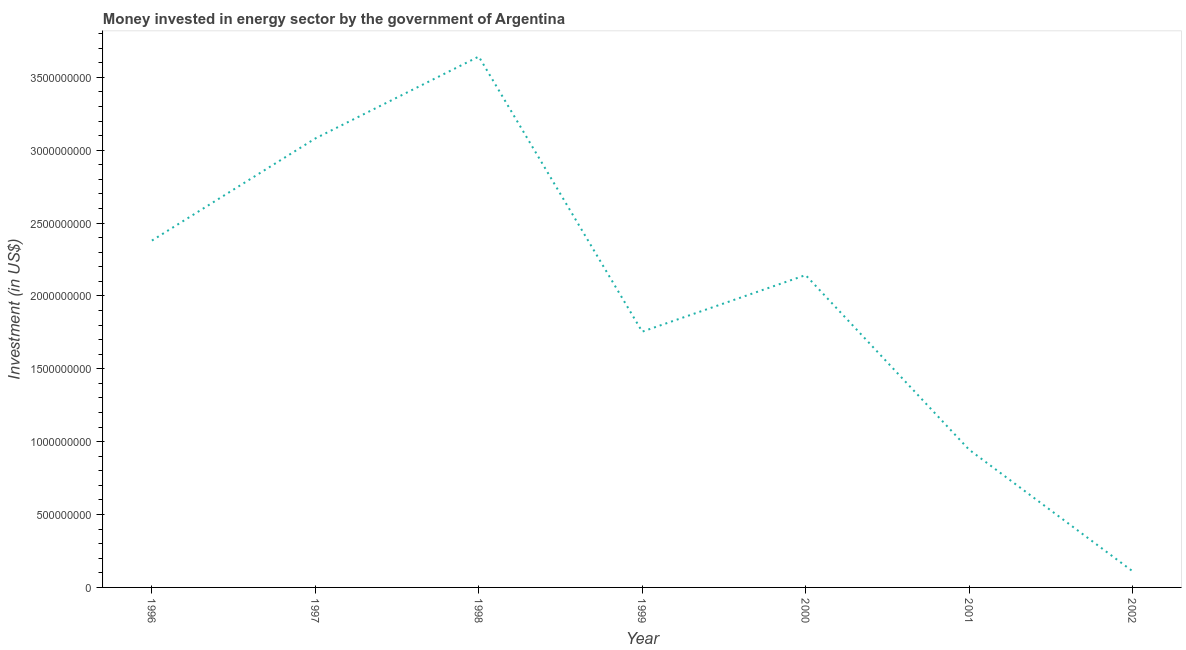What is the investment in energy in 1999?
Offer a terse response. 1.75e+09. Across all years, what is the maximum investment in energy?
Provide a succinct answer. 3.64e+09. Across all years, what is the minimum investment in energy?
Offer a terse response. 1.12e+08. What is the sum of the investment in energy?
Offer a terse response. 1.41e+1. What is the difference between the investment in energy in 1998 and 2001?
Give a very brief answer. 2.70e+09. What is the average investment in energy per year?
Make the answer very short. 2.01e+09. What is the median investment in energy?
Offer a terse response. 2.14e+09. In how many years, is the investment in energy greater than 2100000000 US$?
Make the answer very short. 4. What is the ratio of the investment in energy in 1996 to that in 1997?
Provide a short and direct response. 0.77. Is the investment in energy in 1998 less than that in 2002?
Ensure brevity in your answer.  No. Is the difference between the investment in energy in 1998 and 2000 greater than the difference between any two years?
Offer a very short reply. No. What is the difference between the highest and the second highest investment in energy?
Offer a terse response. 5.62e+08. What is the difference between the highest and the lowest investment in energy?
Your response must be concise. 3.53e+09. In how many years, is the investment in energy greater than the average investment in energy taken over all years?
Give a very brief answer. 4. Does the investment in energy monotonically increase over the years?
Offer a terse response. No. How many years are there in the graph?
Ensure brevity in your answer.  7. What is the difference between two consecutive major ticks on the Y-axis?
Provide a short and direct response. 5.00e+08. What is the title of the graph?
Make the answer very short. Money invested in energy sector by the government of Argentina. What is the label or title of the Y-axis?
Offer a very short reply. Investment (in US$). What is the Investment (in US$) of 1996?
Offer a very short reply. 2.38e+09. What is the Investment (in US$) of 1997?
Your answer should be compact. 3.08e+09. What is the Investment (in US$) of 1998?
Keep it short and to the point. 3.64e+09. What is the Investment (in US$) in 1999?
Give a very brief answer. 1.75e+09. What is the Investment (in US$) in 2000?
Offer a very short reply. 2.14e+09. What is the Investment (in US$) of 2001?
Ensure brevity in your answer.  9.46e+08. What is the Investment (in US$) of 2002?
Provide a short and direct response. 1.12e+08. What is the difference between the Investment (in US$) in 1996 and 1997?
Your response must be concise. -7.01e+08. What is the difference between the Investment (in US$) in 1996 and 1998?
Provide a short and direct response. -1.26e+09. What is the difference between the Investment (in US$) in 1996 and 1999?
Offer a very short reply. 6.25e+08. What is the difference between the Investment (in US$) in 1996 and 2000?
Provide a succinct answer. 2.37e+08. What is the difference between the Investment (in US$) in 1996 and 2001?
Provide a succinct answer. 1.43e+09. What is the difference between the Investment (in US$) in 1996 and 2002?
Offer a terse response. 2.27e+09. What is the difference between the Investment (in US$) in 1997 and 1998?
Offer a terse response. -5.62e+08. What is the difference between the Investment (in US$) in 1997 and 1999?
Ensure brevity in your answer.  1.33e+09. What is the difference between the Investment (in US$) in 1997 and 2000?
Make the answer very short. 9.38e+08. What is the difference between the Investment (in US$) in 1997 and 2001?
Provide a succinct answer. 2.14e+09. What is the difference between the Investment (in US$) in 1997 and 2002?
Make the answer very short. 2.97e+09. What is the difference between the Investment (in US$) in 1998 and 1999?
Offer a very short reply. 1.89e+09. What is the difference between the Investment (in US$) in 1998 and 2000?
Ensure brevity in your answer.  1.50e+09. What is the difference between the Investment (in US$) in 1998 and 2001?
Offer a very short reply. 2.70e+09. What is the difference between the Investment (in US$) in 1998 and 2002?
Your response must be concise. 3.53e+09. What is the difference between the Investment (in US$) in 1999 and 2000?
Your response must be concise. -3.88e+08. What is the difference between the Investment (in US$) in 1999 and 2001?
Your answer should be compact. 8.09e+08. What is the difference between the Investment (in US$) in 1999 and 2002?
Provide a short and direct response. 1.64e+09. What is the difference between the Investment (in US$) in 2000 and 2001?
Your response must be concise. 1.20e+09. What is the difference between the Investment (in US$) in 2000 and 2002?
Your answer should be compact. 2.03e+09. What is the difference between the Investment (in US$) in 2001 and 2002?
Provide a short and direct response. 8.34e+08. What is the ratio of the Investment (in US$) in 1996 to that in 1997?
Make the answer very short. 0.77. What is the ratio of the Investment (in US$) in 1996 to that in 1998?
Give a very brief answer. 0.65. What is the ratio of the Investment (in US$) in 1996 to that in 1999?
Provide a short and direct response. 1.36. What is the ratio of the Investment (in US$) in 1996 to that in 2000?
Your response must be concise. 1.11. What is the ratio of the Investment (in US$) in 1996 to that in 2001?
Your response must be concise. 2.52. What is the ratio of the Investment (in US$) in 1996 to that in 2002?
Give a very brief answer. 21.28. What is the ratio of the Investment (in US$) in 1997 to that in 1998?
Make the answer very short. 0.85. What is the ratio of the Investment (in US$) in 1997 to that in 1999?
Your answer should be compact. 1.75. What is the ratio of the Investment (in US$) in 1997 to that in 2000?
Keep it short and to the point. 1.44. What is the ratio of the Investment (in US$) in 1997 to that in 2001?
Provide a short and direct response. 3.26. What is the ratio of the Investment (in US$) in 1997 to that in 2002?
Offer a very short reply. 27.55. What is the ratio of the Investment (in US$) in 1998 to that in 1999?
Give a very brief answer. 2.08. What is the ratio of the Investment (in US$) in 1998 to that in 2000?
Give a very brief answer. 1.7. What is the ratio of the Investment (in US$) in 1998 to that in 2001?
Offer a terse response. 3.85. What is the ratio of the Investment (in US$) in 1998 to that in 2002?
Your answer should be very brief. 32.57. What is the ratio of the Investment (in US$) in 1999 to that in 2000?
Give a very brief answer. 0.82. What is the ratio of the Investment (in US$) in 1999 to that in 2001?
Ensure brevity in your answer.  1.86. What is the ratio of the Investment (in US$) in 1999 to that in 2002?
Your response must be concise. 15.69. What is the ratio of the Investment (in US$) in 2000 to that in 2001?
Provide a succinct answer. 2.27. What is the ratio of the Investment (in US$) in 2000 to that in 2002?
Ensure brevity in your answer.  19.16. What is the ratio of the Investment (in US$) in 2001 to that in 2002?
Your response must be concise. 8.46. 